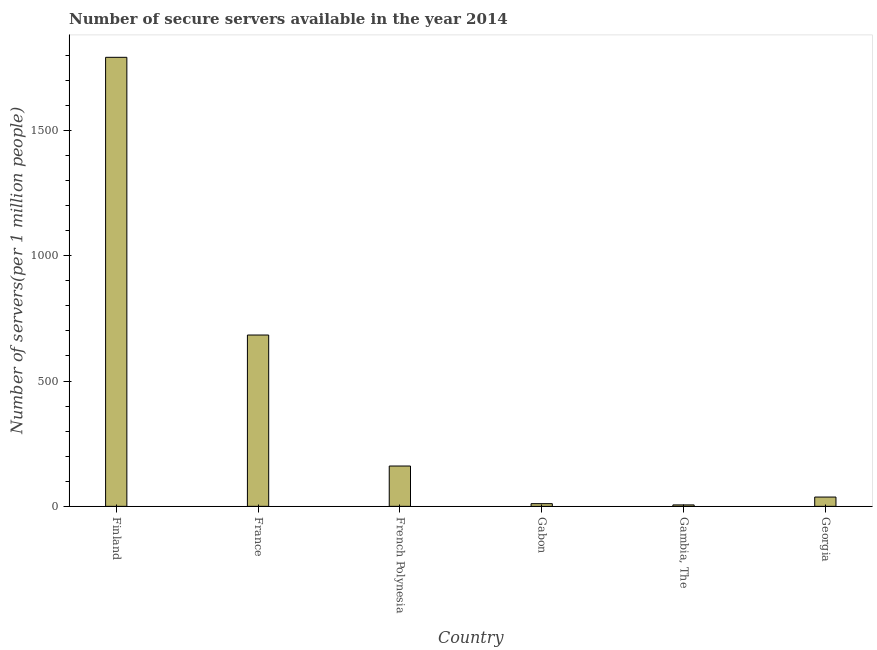Does the graph contain any zero values?
Offer a very short reply. No. What is the title of the graph?
Your answer should be compact. Number of secure servers available in the year 2014. What is the label or title of the X-axis?
Your response must be concise. Country. What is the label or title of the Y-axis?
Offer a terse response. Number of servers(per 1 million people). What is the number of secure internet servers in Finland?
Provide a short and direct response. 1791.31. Across all countries, what is the maximum number of secure internet servers?
Your answer should be compact. 1791.31. Across all countries, what is the minimum number of secure internet servers?
Give a very brief answer. 5.7. In which country was the number of secure internet servers maximum?
Offer a terse response. Finland. In which country was the number of secure internet servers minimum?
Keep it short and to the point. Gambia, The. What is the sum of the number of secure internet servers?
Offer a very short reply. 2689.05. What is the difference between the number of secure internet servers in Gambia, The and Georgia?
Provide a succinct answer. -31.37. What is the average number of secure internet servers per country?
Ensure brevity in your answer.  448.17. What is the median number of secure internet servers?
Ensure brevity in your answer.  98.96. What is the ratio of the number of secure internet servers in Finland to that in Georgia?
Ensure brevity in your answer.  48.31. Is the number of secure internet servers in Gabon less than that in Gambia, The?
Offer a terse response. No. Is the difference between the number of secure internet servers in France and Gabon greater than the difference between any two countries?
Your response must be concise. No. What is the difference between the highest and the second highest number of secure internet servers?
Offer a very short reply. 1107.86. What is the difference between the highest and the lowest number of secure internet servers?
Give a very brief answer. 1785.61. In how many countries, is the number of secure internet servers greater than the average number of secure internet servers taken over all countries?
Your answer should be very brief. 2. Are all the bars in the graph horizontal?
Offer a terse response. No. What is the Number of servers(per 1 million people) in Finland?
Your answer should be compact. 1791.31. What is the Number of servers(per 1 million people) of France?
Make the answer very short. 683.45. What is the Number of servers(per 1 million people) in French Polynesia?
Your answer should be very brief. 160.84. What is the Number of servers(per 1 million people) of Gabon?
Give a very brief answer. 10.67. What is the Number of servers(per 1 million people) in Gambia, The?
Make the answer very short. 5.7. What is the Number of servers(per 1 million people) of Georgia?
Ensure brevity in your answer.  37.08. What is the difference between the Number of servers(per 1 million people) in Finland and France?
Offer a very short reply. 1107.86. What is the difference between the Number of servers(per 1 million people) in Finland and French Polynesia?
Offer a terse response. 1630.47. What is the difference between the Number of servers(per 1 million people) in Finland and Gabon?
Provide a succinct answer. 1780.65. What is the difference between the Number of servers(per 1 million people) in Finland and Gambia, The?
Your answer should be compact. 1785.61. What is the difference between the Number of servers(per 1 million people) in Finland and Georgia?
Your answer should be compact. 1754.23. What is the difference between the Number of servers(per 1 million people) in France and French Polynesia?
Ensure brevity in your answer.  522.61. What is the difference between the Number of servers(per 1 million people) in France and Gabon?
Provide a succinct answer. 672.78. What is the difference between the Number of servers(per 1 million people) in France and Gambia, The?
Your answer should be very brief. 677.74. What is the difference between the Number of servers(per 1 million people) in France and Georgia?
Provide a succinct answer. 646.37. What is the difference between the Number of servers(per 1 million people) in French Polynesia and Gabon?
Your response must be concise. 150.17. What is the difference between the Number of servers(per 1 million people) in French Polynesia and Gambia, The?
Your answer should be compact. 155.14. What is the difference between the Number of servers(per 1 million people) in French Polynesia and Georgia?
Your answer should be very brief. 123.76. What is the difference between the Number of servers(per 1 million people) in Gabon and Gambia, The?
Your answer should be very brief. 4.96. What is the difference between the Number of servers(per 1 million people) in Gabon and Georgia?
Offer a terse response. -26.41. What is the difference between the Number of servers(per 1 million people) in Gambia, The and Georgia?
Offer a terse response. -31.37. What is the ratio of the Number of servers(per 1 million people) in Finland to that in France?
Offer a very short reply. 2.62. What is the ratio of the Number of servers(per 1 million people) in Finland to that in French Polynesia?
Make the answer very short. 11.14. What is the ratio of the Number of servers(per 1 million people) in Finland to that in Gabon?
Make the answer very short. 167.95. What is the ratio of the Number of servers(per 1 million people) in Finland to that in Gambia, The?
Make the answer very short. 314. What is the ratio of the Number of servers(per 1 million people) in Finland to that in Georgia?
Provide a short and direct response. 48.31. What is the ratio of the Number of servers(per 1 million people) in France to that in French Polynesia?
Offer a terse response. 4.25. What is the ratio of the Number of servers(per 1 million people) in France to that in Gabon?
Provide a succinct answer. 64.08. What is the ratio of the Number of servers(per 1 million people) in France to that in Gambia, The?
Your response must be concise. 119.8. What is the ratio of the Number of servers(per 1 million people) in France to that in Georgia?
Offer a very short reply. 18.43. What is the ratio of the Number of servers(per 1 million people) in French Polynesia to that in Gabon?
Provide a succinct answer. 15.08. What is the ratio of the Number of servers(per 1 million people) in French Polynesia to that in Gambia, The?
Your answer should be very brief. 28.19. What is the ratio of the Number of servers(per 1 million people) in French Polynesia to that in Georgia?
Provide a succinct answer. 4.34. What is the ratio of the Number of servers(per 1 million people) in Gabon to that in Gambia, The?
Your answer should be very brief. 1.87. What is the ratio of the Number of servers(per 1 million people) in Gabon to that in Georgia?
Offer a terse response. 0.29. What is the ratio of the Number of servers(per 1 million people) in Gambia, The to that in Georgia?
Offer a terse response. 0.15. 